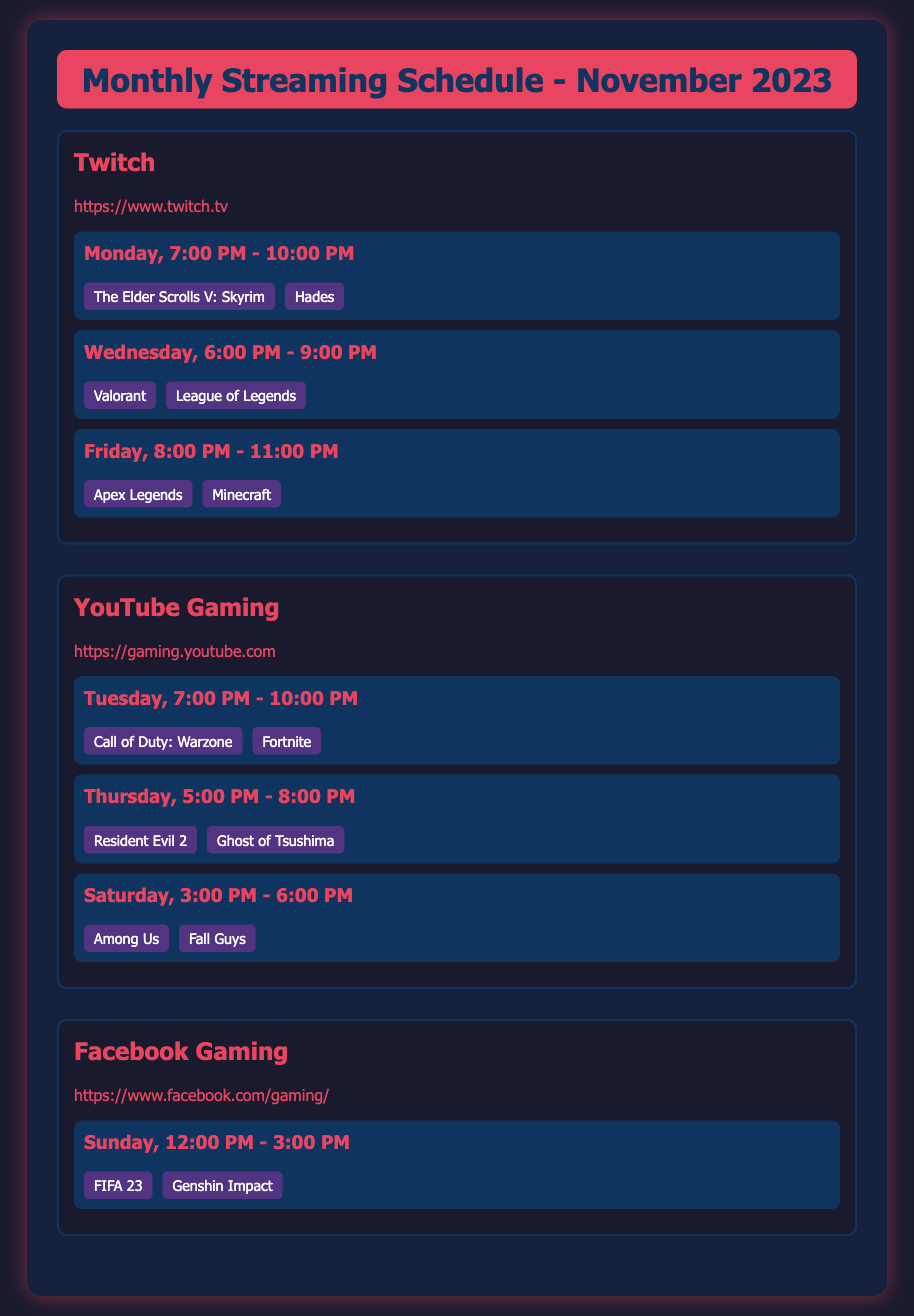What game is scheduled on Monday at 7:00 PM? The game scheduled on Monday at 7:00 PM is "The Elder Scrolls V: Skyrim".
Answer: The Elder Scrolls V: Skyrim Which platform has a streaming slot on Tuesday? The platform with a streaming slot on Tuesday is YouTube Gaming.
Answer: YouTube Gaming How many games are streamed on Friday from 8:00 PM to 11:00 PM? There are two games streamed on Friday from 8:00 PM to 11:00 PM: Apex Legends and Minecraft.
Answer: 2 What is the time slot for Facebook Gaming on Sunday? The time slot for Facebook Gaming on Sunday is 12:00 PM - 3:00 PM.
Answer: 12:00 PM - 3:00 PM Which game pairs are streamed together on Saturday? The game pairs streamed together on Saturday are "Among Us" and "Fall Guys".
Answer: Among Us, Fall Guys On what day is "Resident Evil 2" streamed? "Resident Evil 2" is streamed on Thursday.
Answer: Thursday What are the two games streamed on Wednesday at 6:00 PM? The two games streamed on Wednesday at 6:00 PM are Valorant and League of Legends.
Answer: Valorant, League of Legends How many platforms are listed in the schedule? There are three platforms listed in the schedule.
Answer: 3 What is the URL for Facebook Gaming? The URL for Facebook Gaming is "https://www.facebook.com/gaming/".
Answer: https://www.facebook.com/gaming/ 